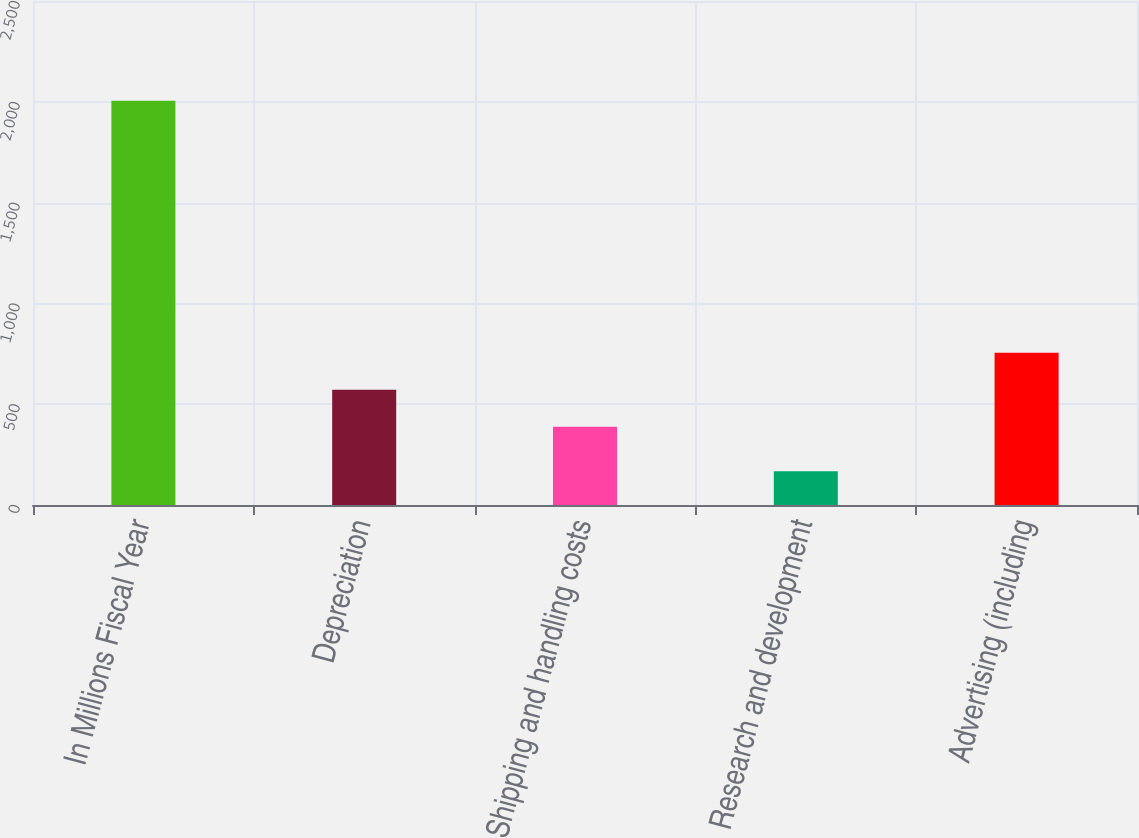<chart> <loc_0><loc_0><loc_500><loc_500><bar_chart><fcel>In Millions Fiscal Year<fcel>Depreciation<fcel>Shipping and handling costs<fcel>Research and development<fcel>Advertising (including<nl><fcel>2005<fcel>571.7<fcel>388<fcel>168<fcel>755.4<nl></chart> 